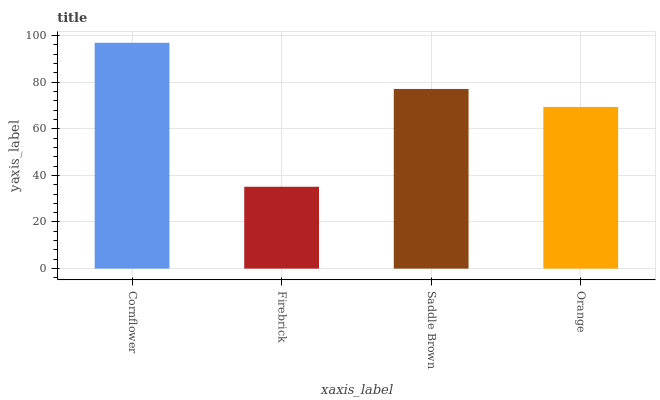Is Saddle Brown the minimum?
Answer yes or no. No. Is Saddle Brown the maximum?
Answer yes or no. No. Is Saddle Brown greater than Firebrick?
Answer yes or no. Yes. Is Firebrick less than Saddle Brown?
Answer yes or no. Yes. Is Firebrick greater than Saddle Brown?
Answer yes or no. No. Is Saddle Brown less than Firebrick?
Answer yes or no. No. Is Saddle Brown the high median?
Answer yes or no. Yes. Is Orange the low median?
Answer yes or no. Yes. Is Firebrick the high median?
Answer yes or no. No. Is Cornflower the low median?
Answer yes or no. No. 